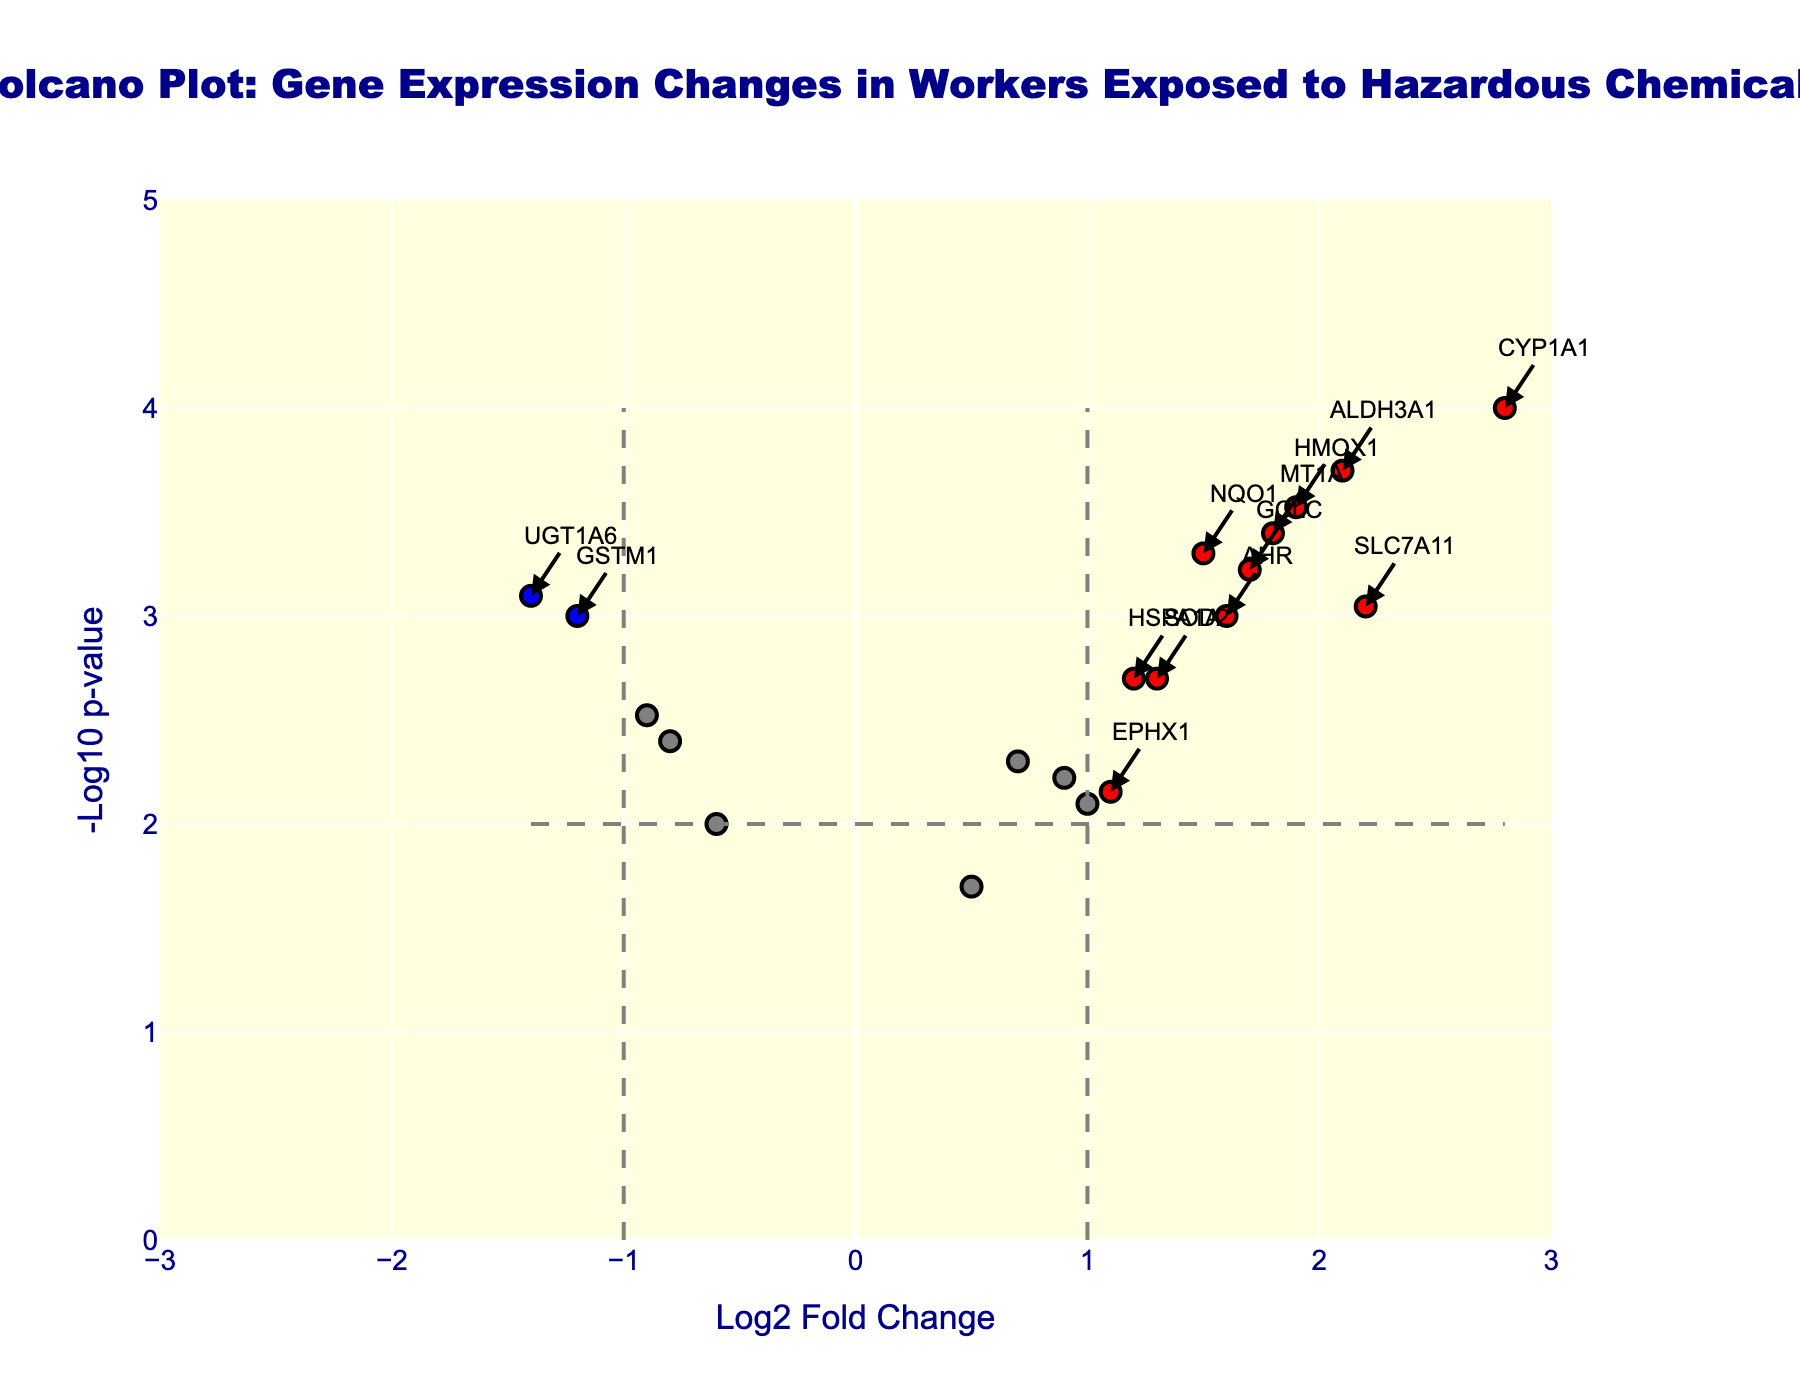What is the title of the plot? The title of the plot is located at the top center of the figure, and it reads "Volcano Plot: Gene Expression Changes in Workers Exposed to Hazardous Chemicals".
Answer: Volcano Plot: Gene Expression Changes in Workers Exposed to Hazardous Chemicals What does the x-axis represent? The x-axis is labeled "Log2 Fold Change". This represents the logarithm base 2 of the fold change in gene expression between workers exposed to hazardous chemicals and the control group.
Answer: Log2 Fold Change What does the y-axis represent? The y-axis is labeled "-Log10 p-value". This represents the negative logarithm base 10 of the p-value, indicating the significance of the gene expression changes.
Answer: -Log10 p-value How many data points are colored red? Data points colored red represent genes with a log2 fold change greater than 1 and a -log10 p-value greater than 2. By counting the red points, we identify there are 10 such genes: CYP1A1, HMOX1, NQO1, ALDH3A1, MT1A, AHR, HSPA1A, GCLC, SLC7A11, EPHX1.
Answer: 10 Which gene has the highest log2 fold change? The gene with the highest log2 fold change is represented by the rightmost data point on the x-axis. This gene is CYP1A1, with a log2 fold change of 2.8.
Answer: CYP1A1 Which gene has the lowest log2 fold change? The gene with the lowest log2 fold change is represented by the leftmost data point on the x-axis. This gene is UGT1A6, with a log2 fold change of -1.4.
Answer: UGT1A6 How many genes are significantly down-regulated? Significantly down-regulated genes have a log2 fold change less than -1 and a -log10 p-value greater than 2. From the plot, these genes are GSTM1 and UGT1A6.
Answer: 2 Which genes have a log2 fold change between 1.5 and 2 and a -log10 p-value greater than 3? Genes within a specific log2 fold change range and with high significance are seen by identifying their position on the plot. The genes meeting these criteria are HMOX1 and ALDH3A1.
Answer: HMOX1 and ALDH3A1 What is the threshold for significant gene expression changes? The threshold for significant gene expression changes is indicated by the dashed lines. For the x-axis (log2 fold change), it's 1 and -1; for the y-axis (-log10 p-value), it's 2.
Answer: log2 fold change of 1 and -1, -log10 p-value of 2 Which gene has the highest level of significance (lowest p-value)? The gene with the highest significance is indicated by the highest data point on the y-axis, which corresponds to the gene CYP1A1 with a -log10 p-value of 4.
Answer: CYP1A1 